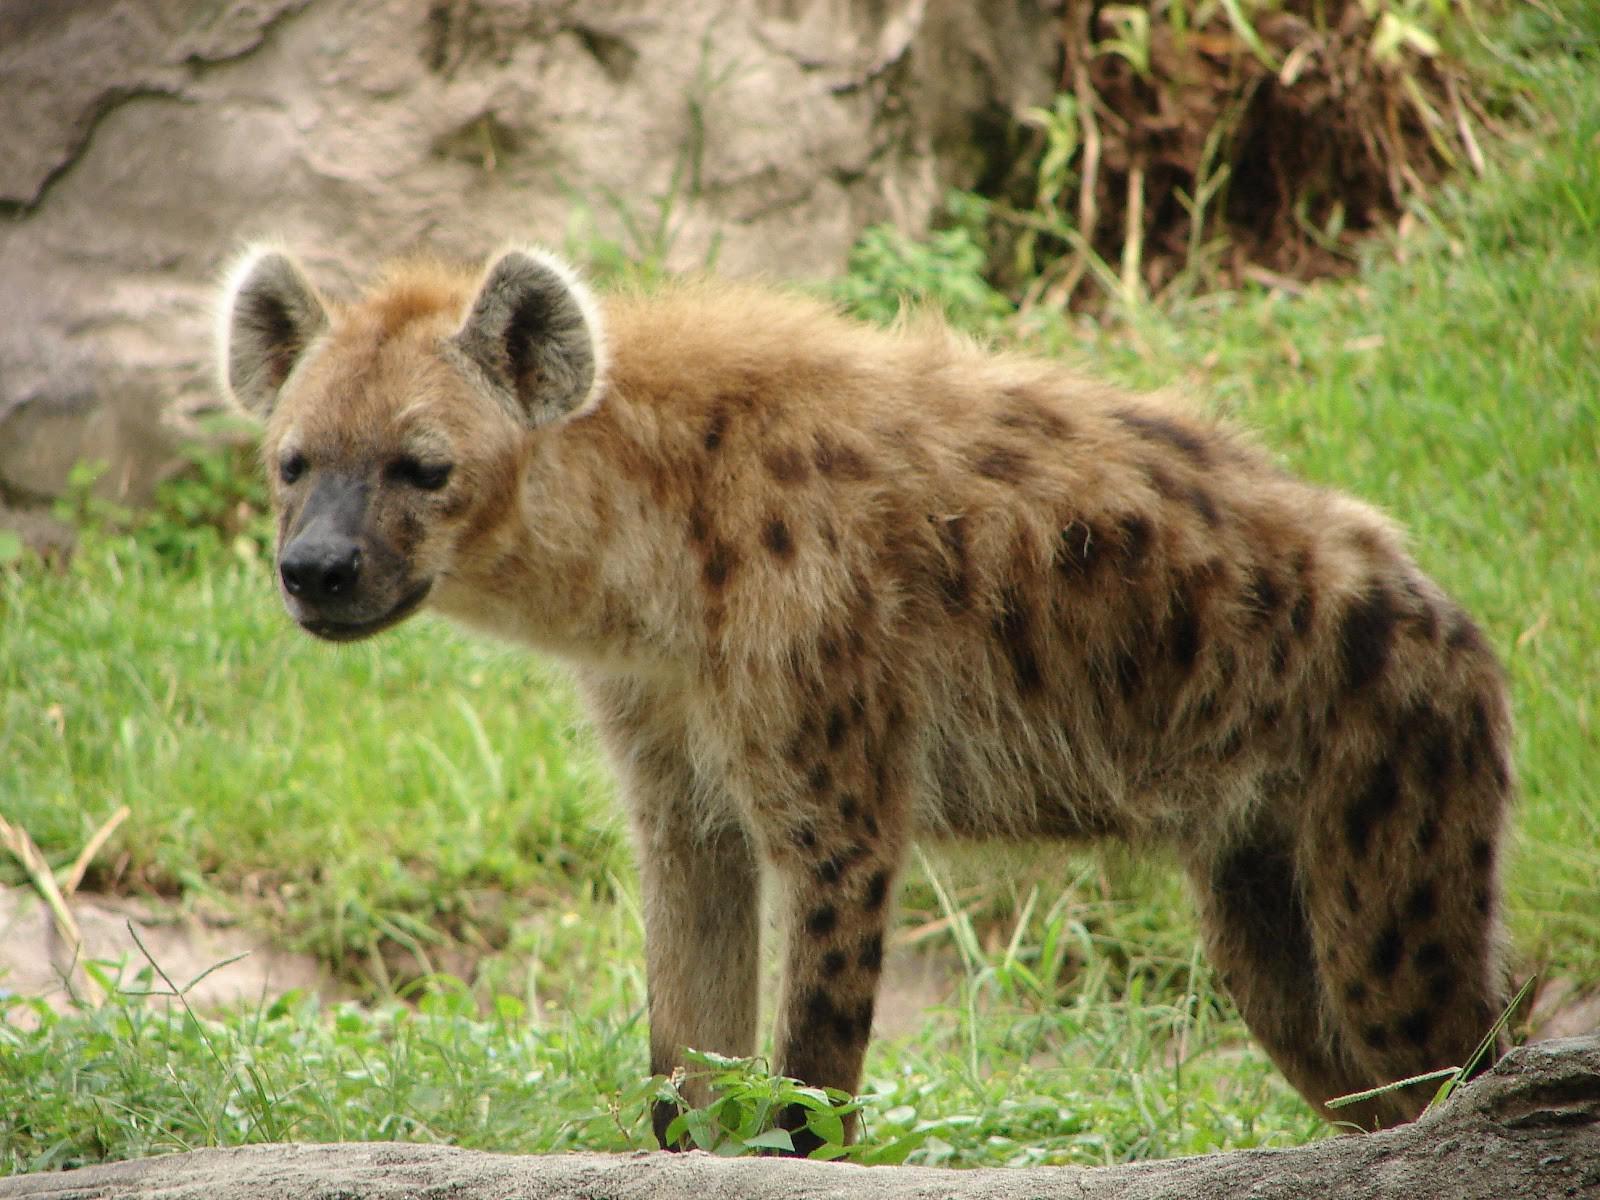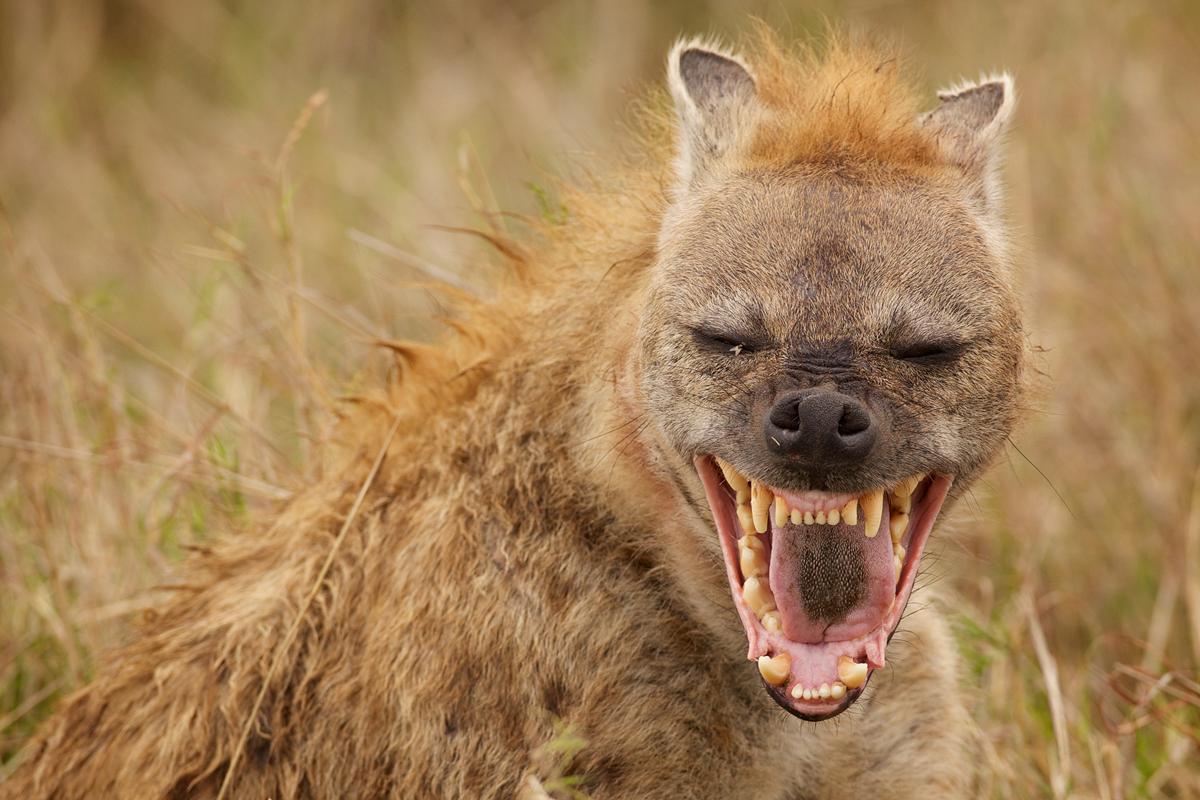The first image is the image on the left, the second image is the image on the right. Given the left and right images, does the statement "The hyena in the right image is baring its teeth." hold true? Answer yes or no. Yes. 